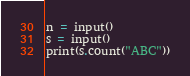<code> <loc_0><loc_0><loc_500><loc_500><_Python_>n = input()
s = input()
print(s.count("ABC"))</code> 